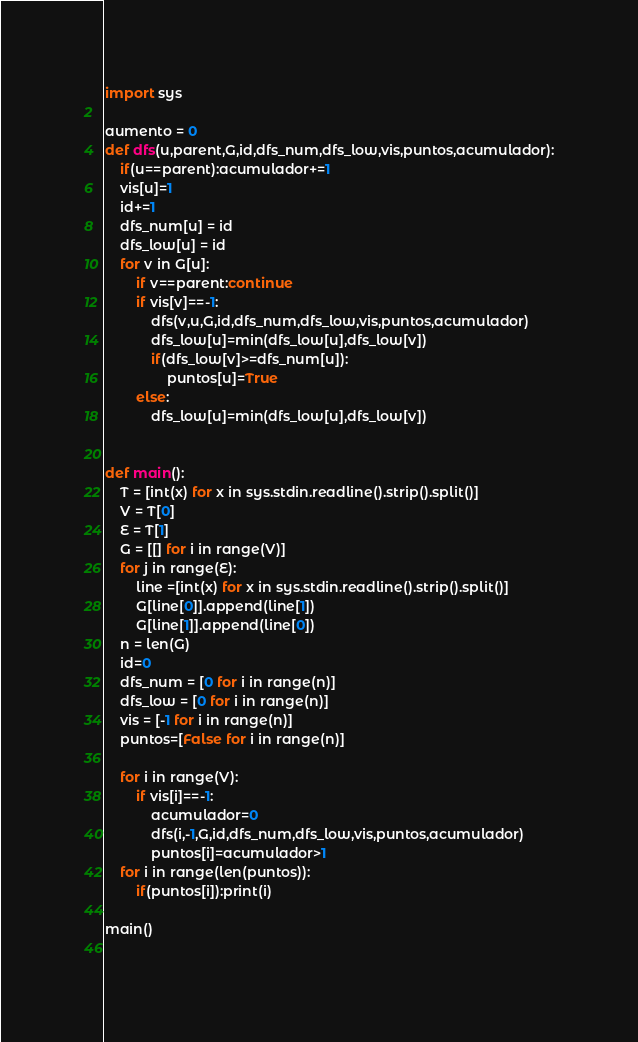<code> <loc_0><loc_0><loc_500><loc_500><_Python_>import sys

aumento = 0
def dfs(u,parent,G,id,dfs_num,dfs_low,vis,puntos,acumulador):
    if(u==parent):acumulador+=1
    vis[u]=1
    id+=1
    dfs_num[u] = id
    dfs_low[u] = id
    for v in G[u]:
        if v==parent:continue
        if vis[v]==-1:
            dfs(v,u,G,id,dfs_num,dfs_low,vis,puntos,acumulador)
            dfs_low[u]=min(dfs_low[u],dfs_low[v])
            if(dfs_low[v]>=dfs_num[u]):
                puntos[u]=True
        else:
            dfs_low[u]=min(dfs_low[u],dfs_low[v])
    

def main():
    T = [int(x) for x in sys.stdin.readline().strip().split()]
    V = T[0]
    E = T[1]
    G = [[] for i in range(V)]
    for j in range(E):
        line =[int(x) for x in sys.stdin.readline().strip().split()]
        G[line[0]].append(line[1])
        G[line[1]].append(line[0])
    n = len(G)
    id=0
    dfs_num = [0 for i in range(n)]
    dfs_low = [0 for i in range(n)]
    vis = [-1 for i in range(n)]
    puntos=[False for i in range(n)]

    for i in range(V):
        if vis[i]==-1:
            acumulador=0
            dfs(i,-1,G,id,dfs_num,dfs_low,vis,puntos,acumulador)
            puntos[i]=acumulador>1
    for i in range(len(puntos)):
        if(puntos[i]):print(i)

main()
            

</code> 